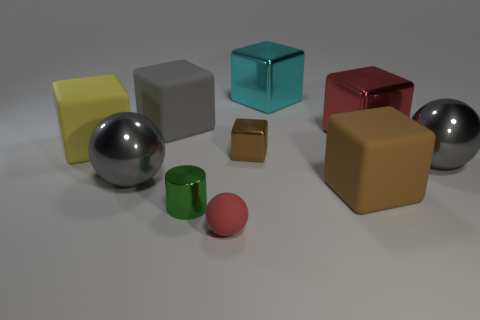Do the tiny green cylinder and the red object that is behind the large yellow matte block have the same material?
Offer a very short reply. Yes. How many other things are the same shape as the red metal thing?
Offer a very short reply. 5. What material is the brown block behind the large matte cube that is to the right of the large gray object that is behind the red metallic thing made of?
Your answer should be compact. Metal. Are there the same number of small shiny cubes that are in front of the small metallic block and big yellow rubber blocks?
Ensure brevity in your answer.  No. Does the large gray ball that is on the right side of the large cyan block have the same material as the gray sphere that is left of the cyan metal object?
Your answer should be very brief. Yes. Is the shape of the big gray metal thing that is to the right of the small rubber object the same as the gray shiny thing left of the large red metal block?
Your answer should be compact. Yes. Are there fewer gray matte cubes right of the large cyan metal block than yellow cylinders?
Make the answer very short. No. What number of matte objects have the same color as the small cube?
Make the answer very short. 1. There is a ball that is in front of the small green cylinder; how big is it?
Provide a short and direct response. Small. The gray object on the right side of the small object that is in front of the small shiny object that is in front of the brown shiny block is what shape?
Your answer should be very brief. Sphere. 